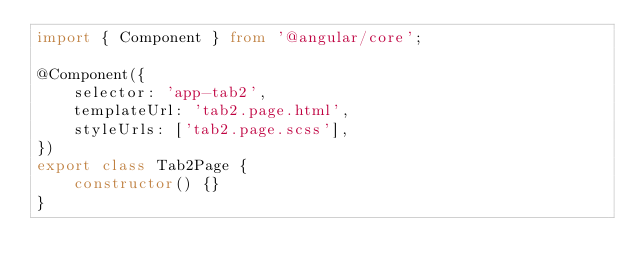<code> <loc_0><loc_0><loc_500><loc_500><_TypeScript_>import { Component } from '@angular/core';

@Component({
    selector: 'app-tab2',
    templateUrl: 'tab2.page.html',
    styleUrls: ['tab2.page.scss'],
})
export class Tab2Page {
    constructor() {}
}
</code> 